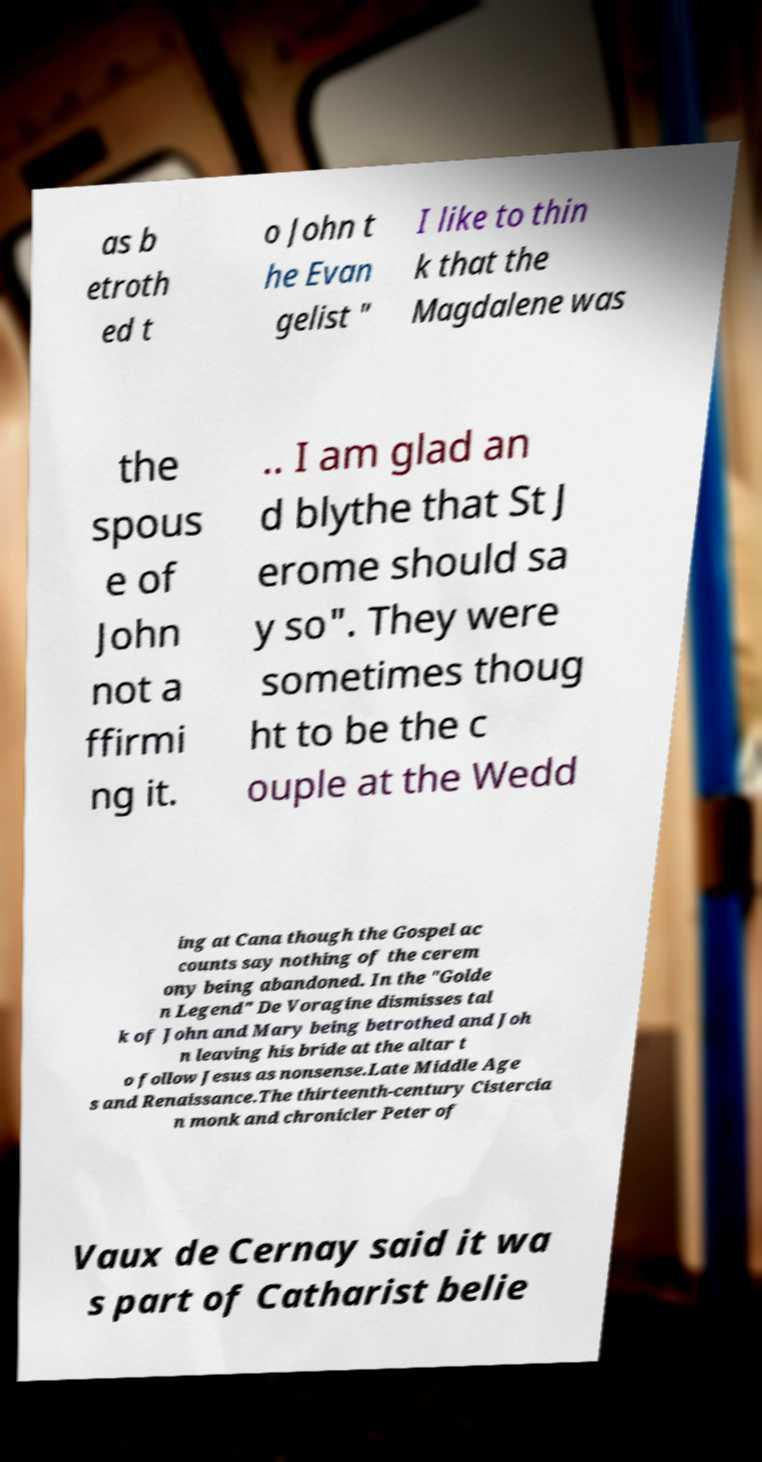Please identify and transcribe the text found in this image. as b etroth ed t o John t he Evan gelist " I like to thin k that the Magdalene was the spous e of John not a ffirmi ng it. .. I am glad an d blythe that St J erome should sa y so". They were sometimes thoug ht to be the c ouple at the Wedd ing at Cana though the Gospel ac counts say nothing of the cerem ony being abandoned. In the "Golde n Legend" De Voragine dismisses tal k of John and Mary being betrothed and Joh n leaving his bride at the altar t o follow Jesus as nonsense.Late Middle Age s and Renaissance.The thirteenth-century Cistercia n monk and chronicler Peter of Vaux de Cernay said it wa s part of Catharist belie 